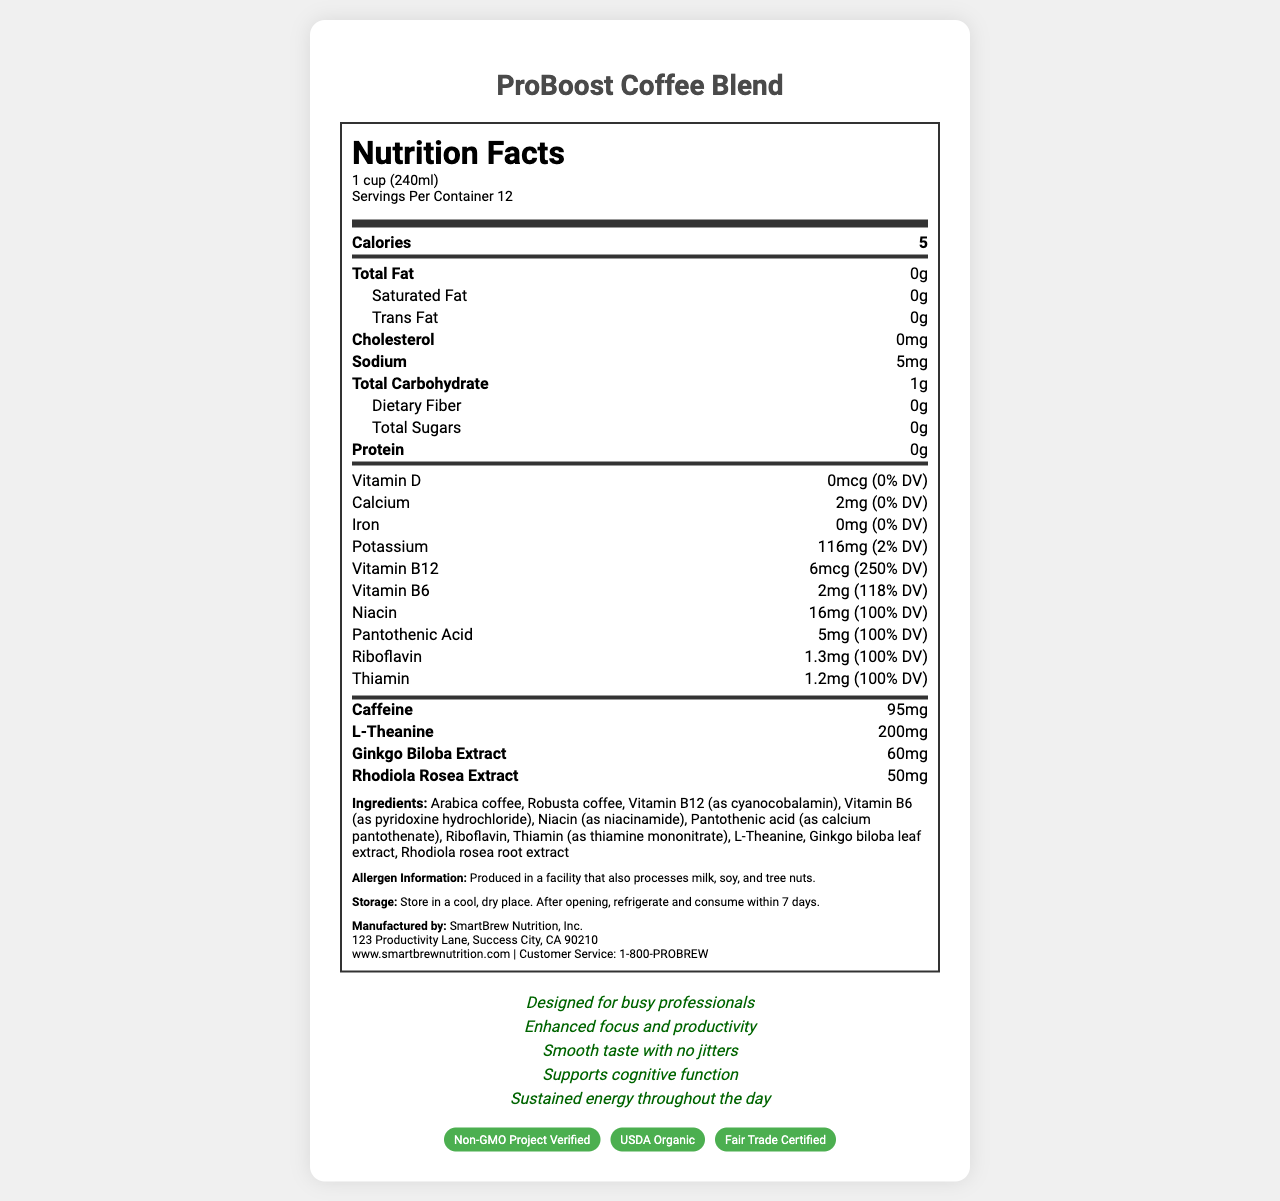What is the serving size of ProBoost Coffee Blend? The serving size is listed under the "Nutrition Facts" heading, specifying "1 cup (240ml)".
Answer: 1 cup (240ml) How many calories are in one serving of ProBoost Coffee Blend? The calorie content is shown in bold under the "Nutrition Facts" section.
Answer: 5 calories How much Vitamin B12 is in one serving of ProBoost Coffee Blend? The amount of Vitamin B12 is listed in the vitamins section, indicating the specific micrograms and daily value percentage.
Answer: 6mcg (250% DV) What are the main vitamins included in ProBoost Coffee Blend? These vitamins are listed under the vitamins section with their respective amounts and daily values.
Answer: Vitamin B12, Vitamin B6, Niacin, Pantothenic Acid, Riboflavin, Thiamin How much caffeine is in one serving of ProBoost Coffee Blend? The caffeine content is listed under the nutrient rows, specifically highlighting it in bold.
Answer: 95mg What allergens might be present in ProBoost Coffee Blend? The allergen information specifies that the product is produced in a facility that also processes these allergens.
Answer: Milk, soy, and tree nuts What certification claims does ProBoost Coffee Blend have? A. Non-GMO Project Verified B. USDA Organic C. Fair Trade Certified D. All of the above The certifications section lists all three certifications: Non-GMO Project Verified, USDA Organic, and Fair Trade Certified.
Answer: D Which of the following marketing claims is not made about ProBoost Coffee Blend? I. Designed for busy professionals II. Enhanced focus and productivity III. Artificially flavored IV. Supports cognitive function The marketing claims listed do not mention "Artificially flavored," only the other three claims.
Answer: III Is ProBoost Coffee Blend suitable for individuals with a gluten allergy? The document does not provide information on gluten or its presence in the product.
Answer: Not enough information How should ProBoost Coffee Blend be stored after opening? The storage instructions specify that the product should be refrigerated and consumed within a week after opening.
Answer: Refrigerate and consume within 7 days Describe the main idea of the document. The document provides comprehensive data on the ProBoost Coffee Blend, focusing on its nutritional benefits, vitamins, and additional components that cater to busy professionals seeking enhanced focus and productivity.
Answer: The main idea of the document is to provide detailed nutritional information about the ProBoost Coffee Blend, a vitamin-enhanced coffee targeting productivity-focused professionals. It includes serving information, nutritional content, ingredients, allergens, storage instructions, manufacturer details, marketing claims, and certifications. Who is the manufacturer of ProBoost Coffee Blend? The manufacturer details section lists SmartBrew Nutrition, Inc. as the manufacturer, along with its address and contact information.
Answer: SmartBrew Nutrition, Inc. Can ProBoost Coffee Blend contribute significantly to your daily potassium intake? The document states that each serving contains 116mg of potassium, which is only 2% of the daily value, indicating it does not contribute significantly.
Answer: No 